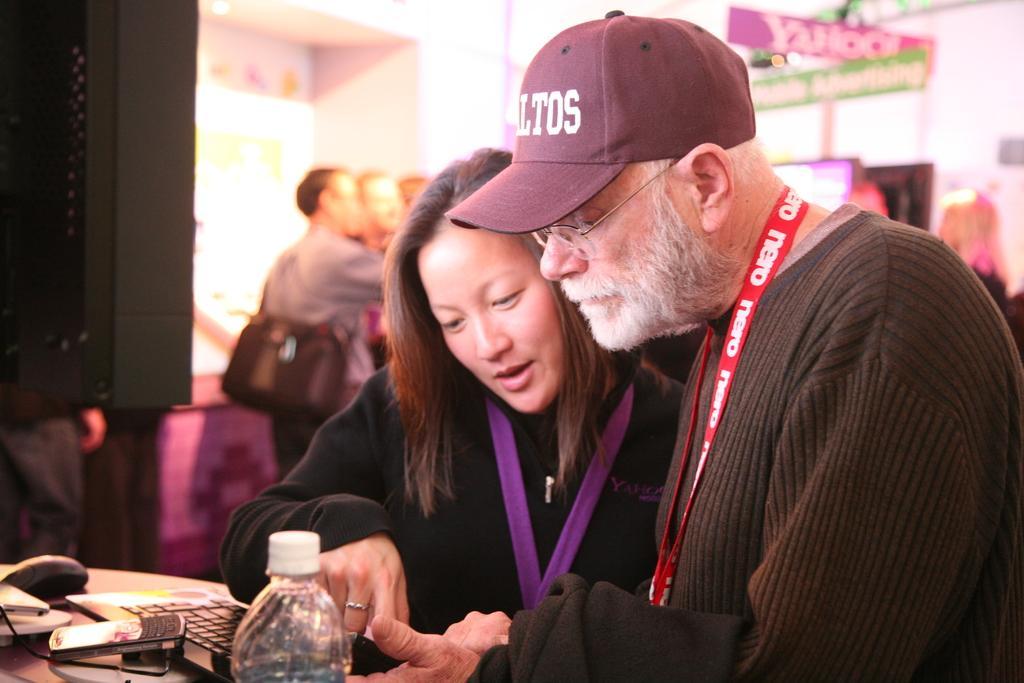Could you give a brief overview of what you see in this image? This picture is clicked inside the room. On the right we can see the two persons wearing t-shirts and seems to be standing. On the left we can see a water bottle, mobile phone and some other objects are placed on the top of the table. In the background we can see the group of persons, text on the banners and we can see the ceiling light and many other objects and we can see the wall and a sling bag. 